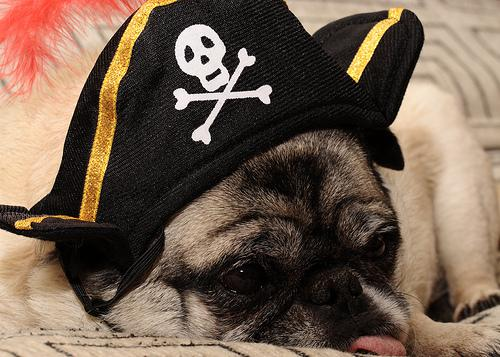Question: who is in the picture?
Choices:
A. A cow.
B. A dog.
C. A pig.
D. A turkey.
Answer with the letter. Answer: B Question: where is the hat?
Choices:
A. On the hat rack.
B. On the dog's head.
C. In the car.
D. On the boy's head.
Answer with the letter. Answer: B Question: where is the dog laying?
Choices:
A. On a pillow.
B. The floor.
C. On the bed.
D. On the sofa.
Answer with the letter. Answer: B Question: what is the main color of the hat?
Choices:
A. Brown.
B. Gray.
C. Black.
D. White.
Answer with the letter. Answer: C 